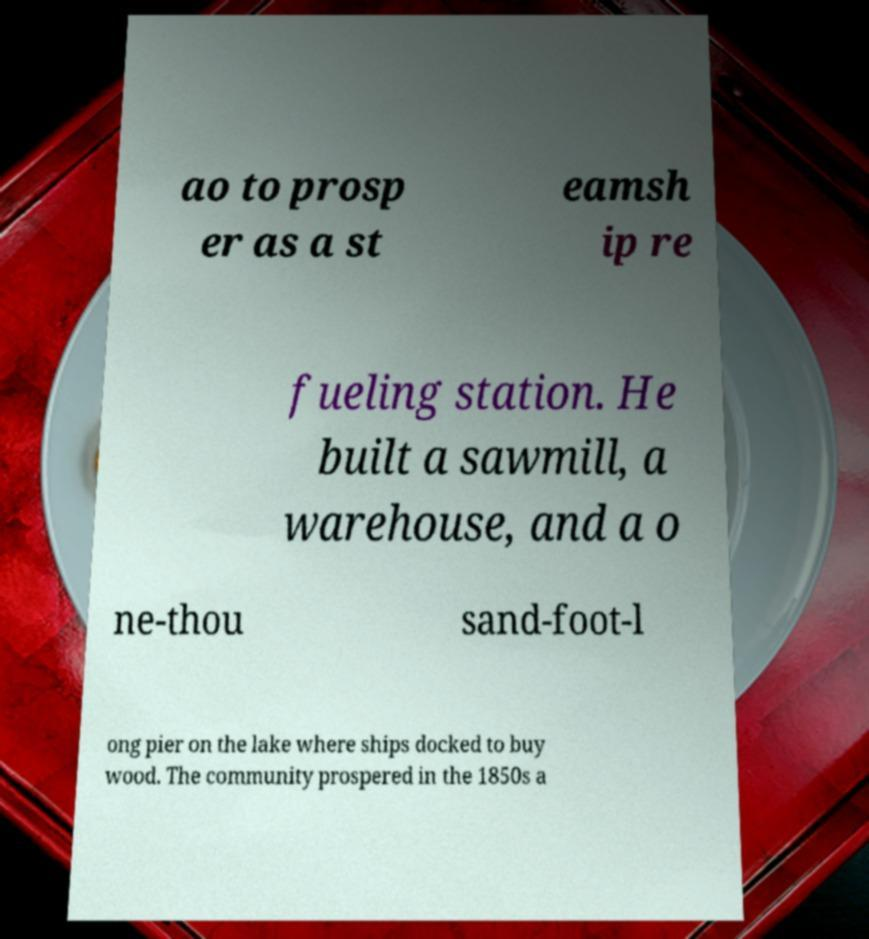What messages or text are displayed in this image? I need them in a readable, typed format. ao to prosp er as a st eamsh ip re fueling station. He built a sawmill, a warehouse, and a o ne-thou sand-foot-l ong pier on the lake where ships docked to buy wood. The community prospered in the 1850s a 